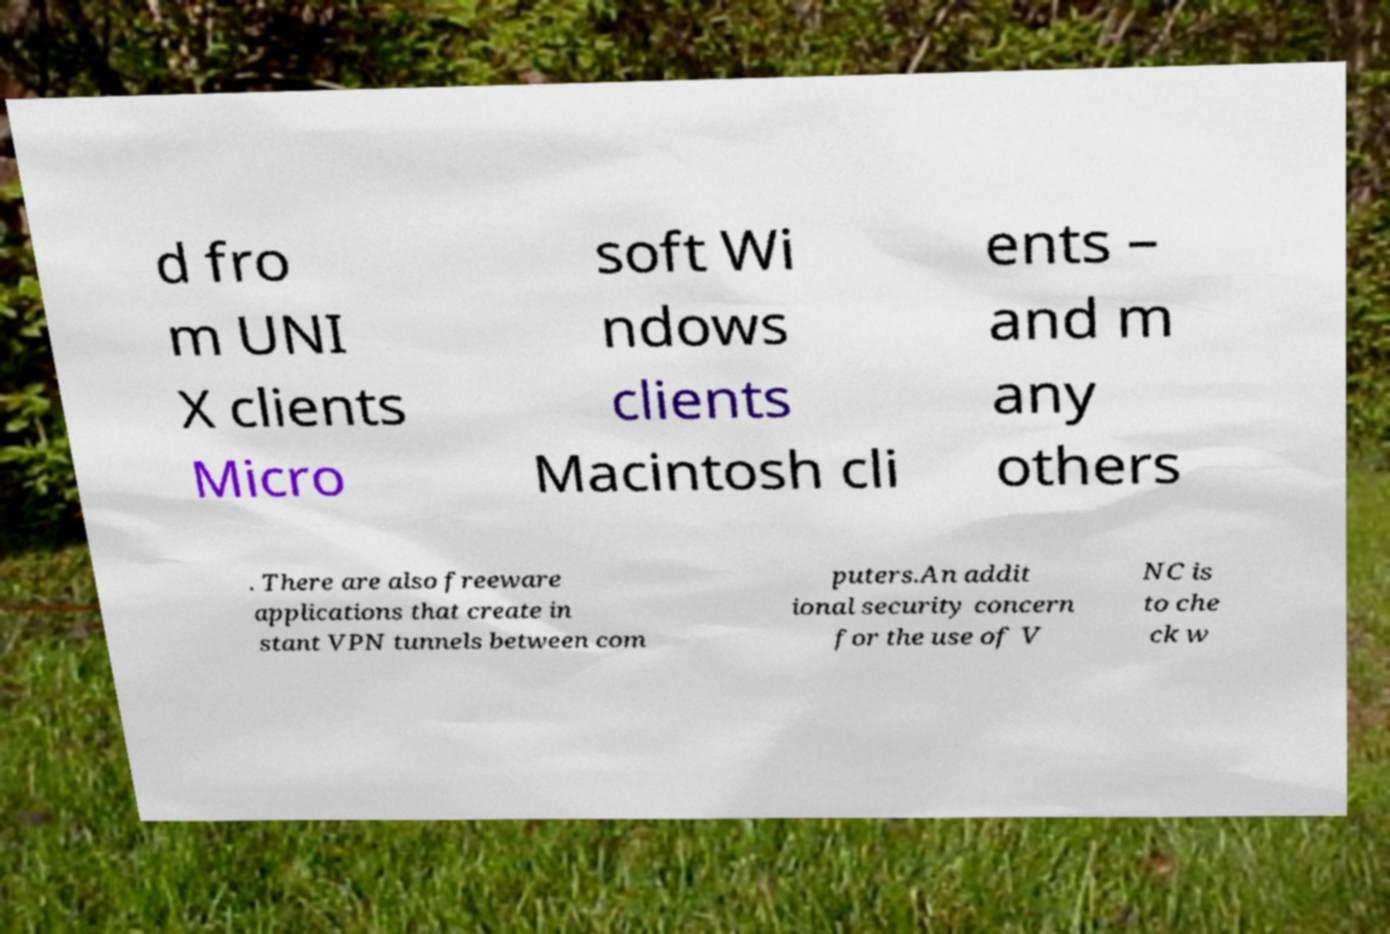For documentation purposes, I need the text within this image transcribed. Could you provide that? d fro m UNI X clients Micro soft Wi ndows clients Macintosh cli ents – and m any others . There are also freeware applications that create in stant VPN tunnels between com puters.An addit ional security concern for the use of V NC is to che ck w 